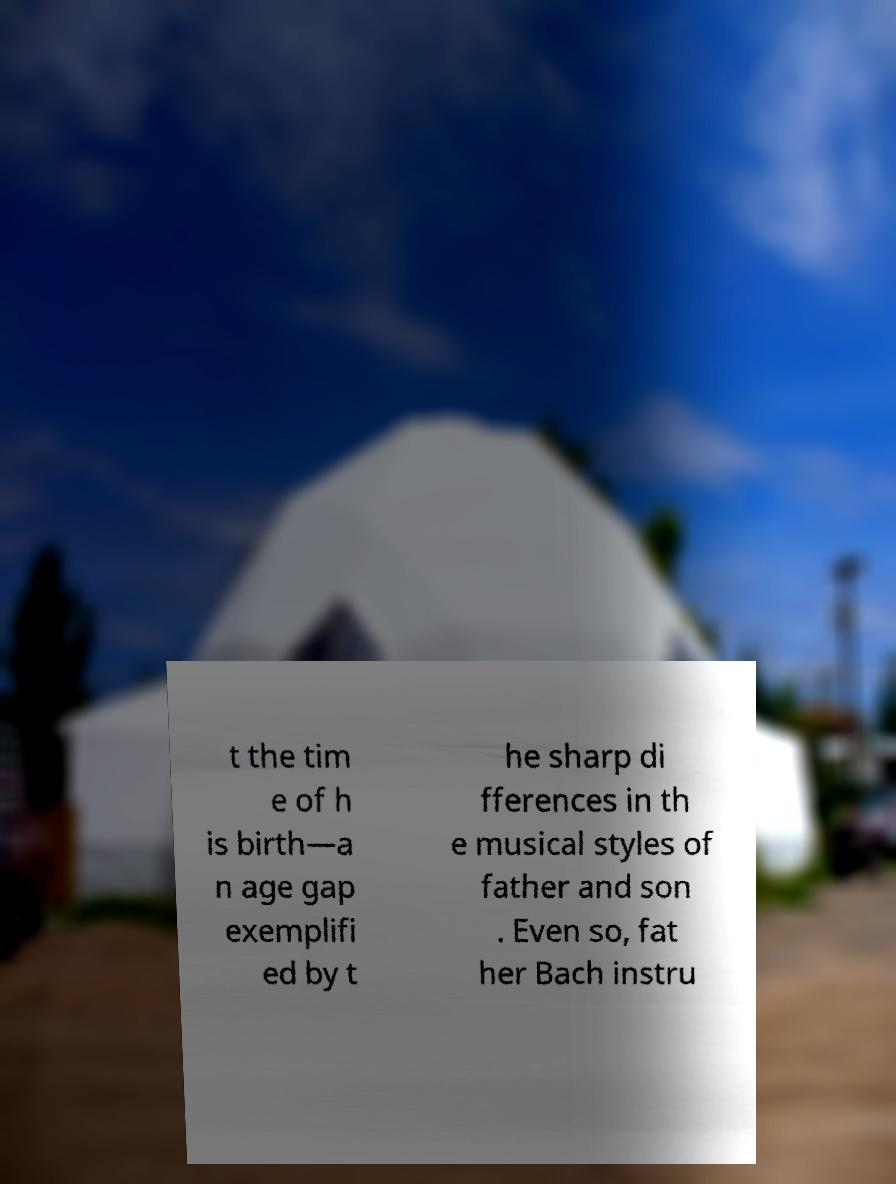Could you extract and type out the text from this image? t the tim e of h is birth—a n age gap exemplifi ed by t he sharp di fferences in th e musical styles of father and son . Even so, fat her Bach instru 